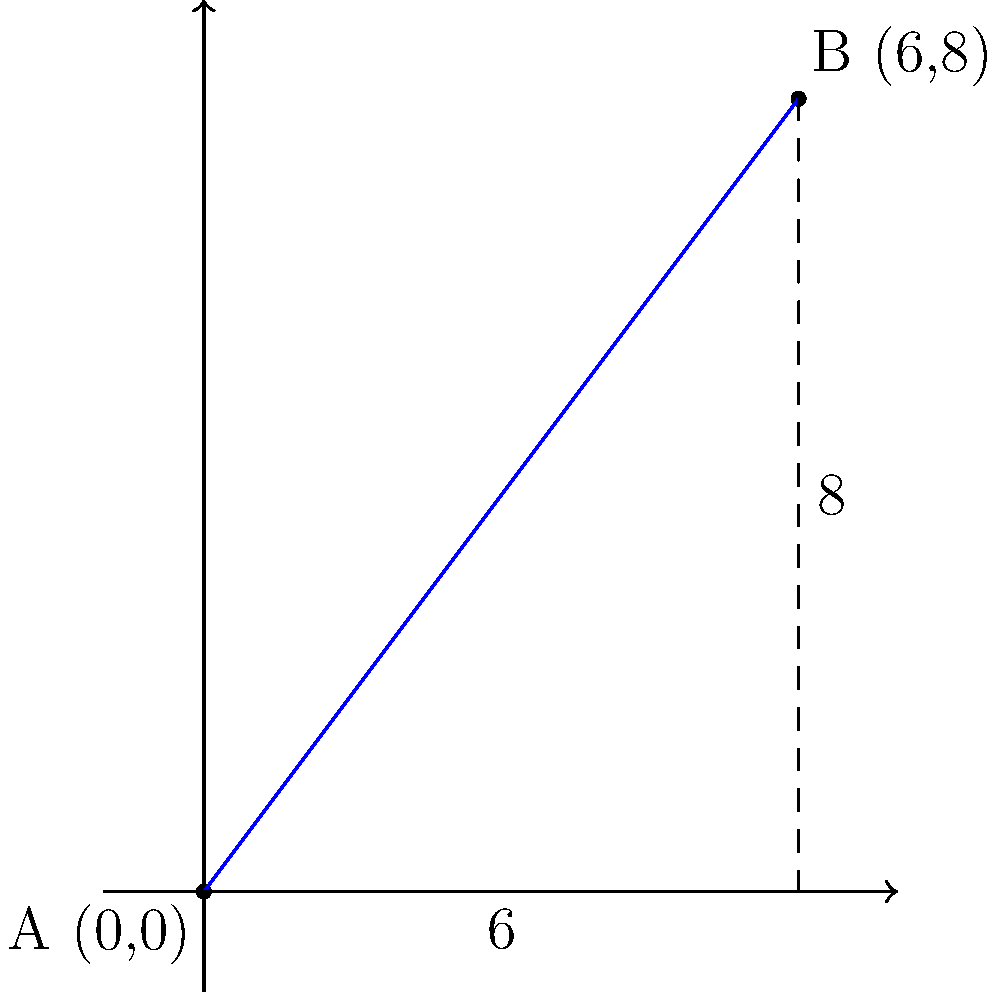Two popular ska punk concert venues are located in different parts of the city. On a coordinate grid, Venue A is at (0,0) and Venue B is at (6,8). As the organizer of a ska punk fan club, you need to calculate the straight-line distance between these venues for planning a concert-hopping event. Using the Pythagorean theorem, determine the distance between Venue A and Venue B. To find the distance between two points on a coordinate plane, we can use the Pythagorean theorem. Let's approach this step-by-step:

1. Identify the coordinates:
   Venue A: (0,0)
   Venue B: (6,8)

2. Calculate the difference in x-coordinates:
   $\Delta x = 6 - 0 = 6$

3. Calculate the difference in y-coordinates:
   $\Delta y = 8 - 0 = 8$

4. Apply the Pythagorean theorem:
   $distance = \sqrt{(\Delta x)^2 + (\Delta y)^2}$

5. Substitute the values:
   $distance = \sqrt{6^2 + 8^2}$

6. Calculate:
   $distance = \sqrt{36 + 64}$
   $distance = \sqrt{100}$

7. Simplify:
   $distance = 10$

Therefore, the straight-line distance between Venue A and Venue B is 10 units.
Answer: 10 units 